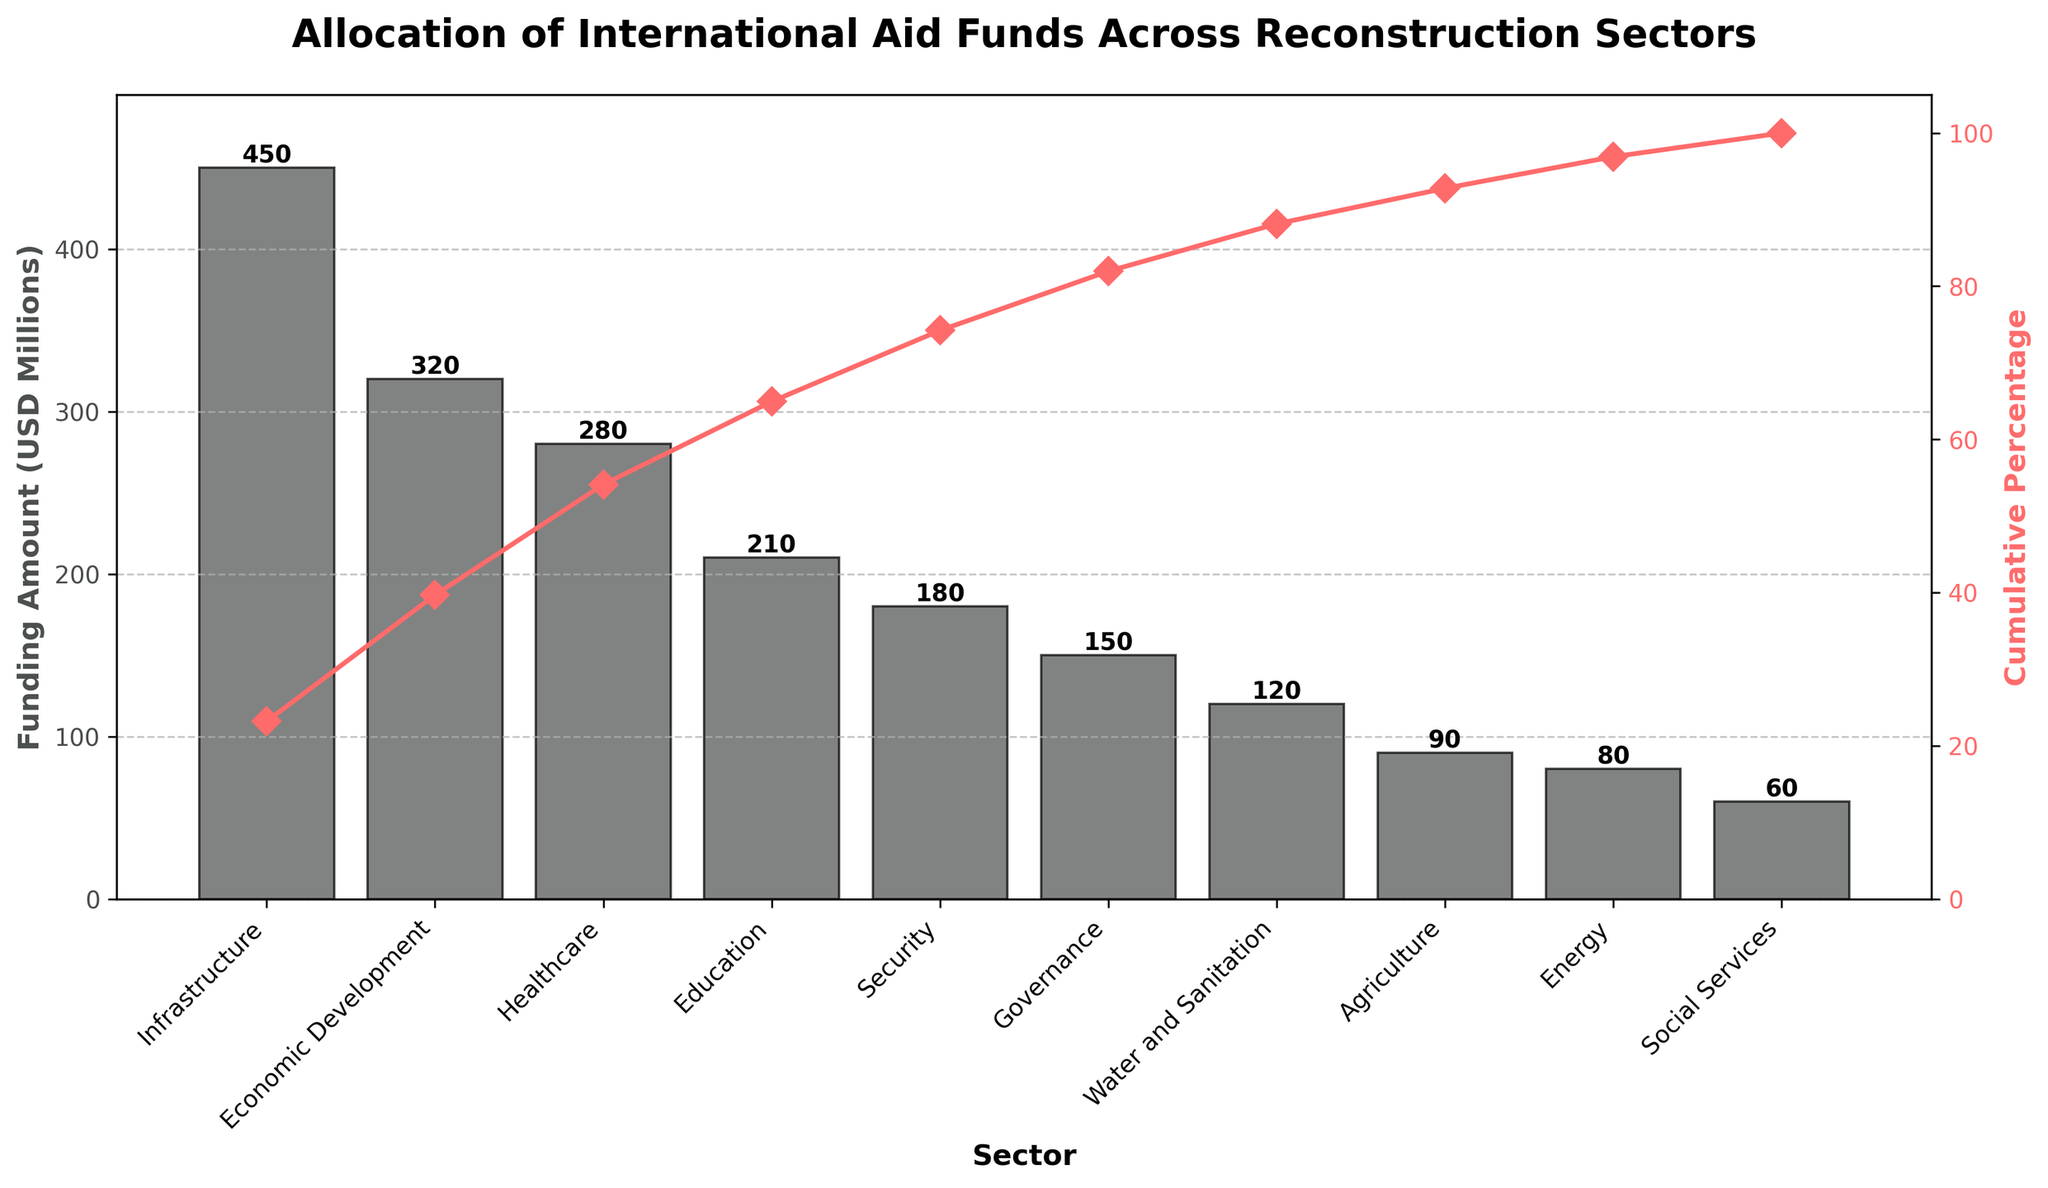What is the sector with the highest funding amount? The sector with the highest funding amount can be identified by looking at the tallest bar in the chart.
Answer: Infrastructure What is the total funding amount covered by the sectors listed in the chart? The total funding amount is the sum of all individual funding amounts shown in the bar chart.
Answer: 1940 million USD Which sector ranks third in terms of funding amount? To find the third-ranked sector in funding amount, locate the third tallest bar in the chart.
Answer: Healthcare What is the cumulative percentage for the Healthcare sector? The cumulative percentage for Healthcare can be identified by locating the corresponding point on the cumulative percentage line.
Answer: 54.64% How does the funding for Education compare to that for Security? Compare the heights of the bars for Education and Security to see which is taller.
Answer: Education (210M vs 180M) How many sectors have a funding amount of more than 100 million USD? Count the number of bars that reach or exceed the 100 million USD mark on the y-axis.
Answer: 6 sectors What is the cumulative percentage after including funding for Economic Development? Calculate the cumulative percentage up to Economic Development by summing the percentages for all sectors up to and including it.
Answer: 39.69% Which sector has the lowest funding amount, and what is it? Identify the shortest bar on the chart to determine the sector with the lowest funding amount.
Answer: Social Services, 60M What approximate percentage of the total funding is allocated to Infrastructure and Economic Development combined? Sum the funding amounts for Infrastructure and Economic Development, then calculate their combined percentage of the total funding.
Answer: Approximately 39.69% By approximately what percentage does the funding for Governance sector fall below that of Security? Subtract the Governance funding amount from the Security funding amount, divide by Security's funding amount, and convert to a percentage.
Answer: Approximately 16.67% 